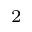Convert formula to latex. <formula><loc_0><loc_0><loc_500><loc_500>^ { 2 }</formula> 